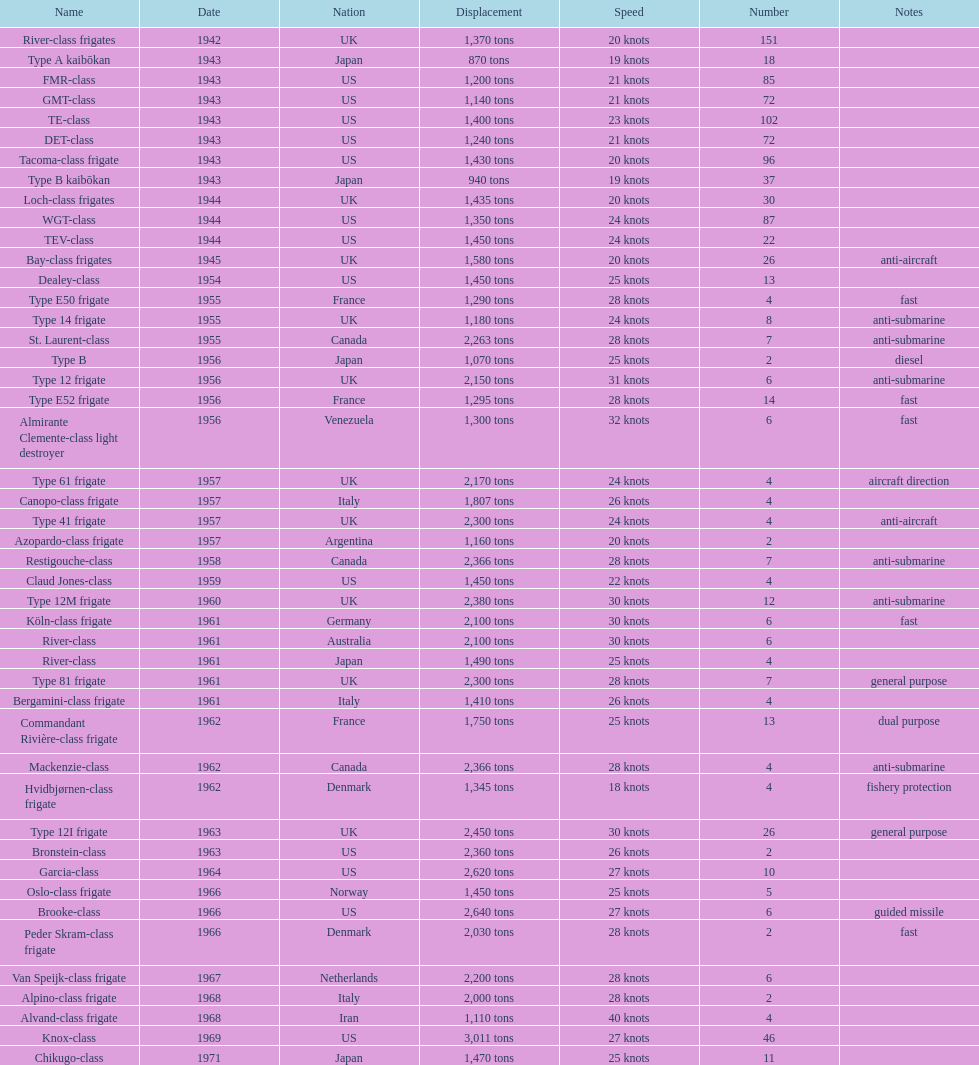Which of the boats listed is the fastest? Alvand-class frigate. 